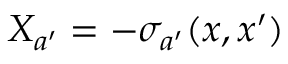<formula> <loc_0><loc_0><loc_500><loc_500>X _ { a ^ { \prime } } = - \sigma _ { a ^ { \prime } } ( x , x ^ { \prime } )</formula> 